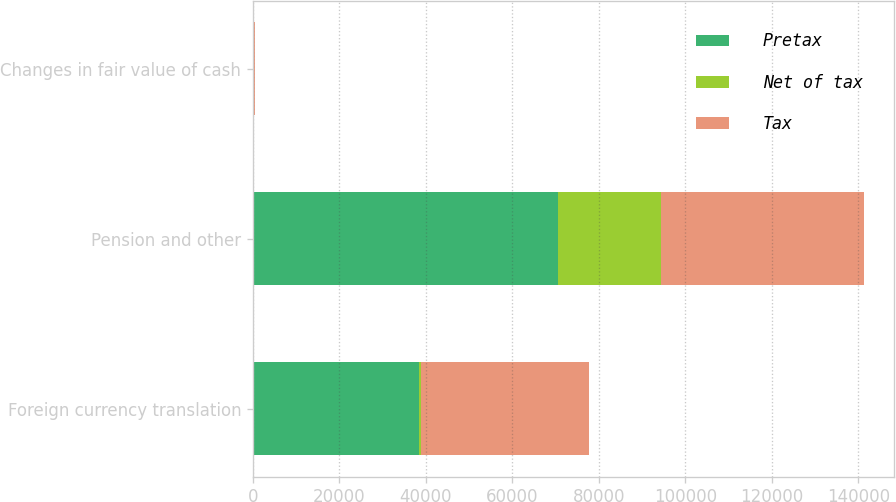<chart> <loc_0><loc_0><loc_500><loc_500><stacked_bar_chart><ecel><fcel>Foreign currency translation<fcel>Pension and other<fcel>Changes in fair value of cash<nl><fcel>Pretax<fcel>38521<fcel>70642<fcel>195<nl><fcel>Net of tax<fcel>359<fcel>23632<fcel>70<nl><fcel>Tax<fcel>38880<fcel>47010<fcel>125<nl></chart> 